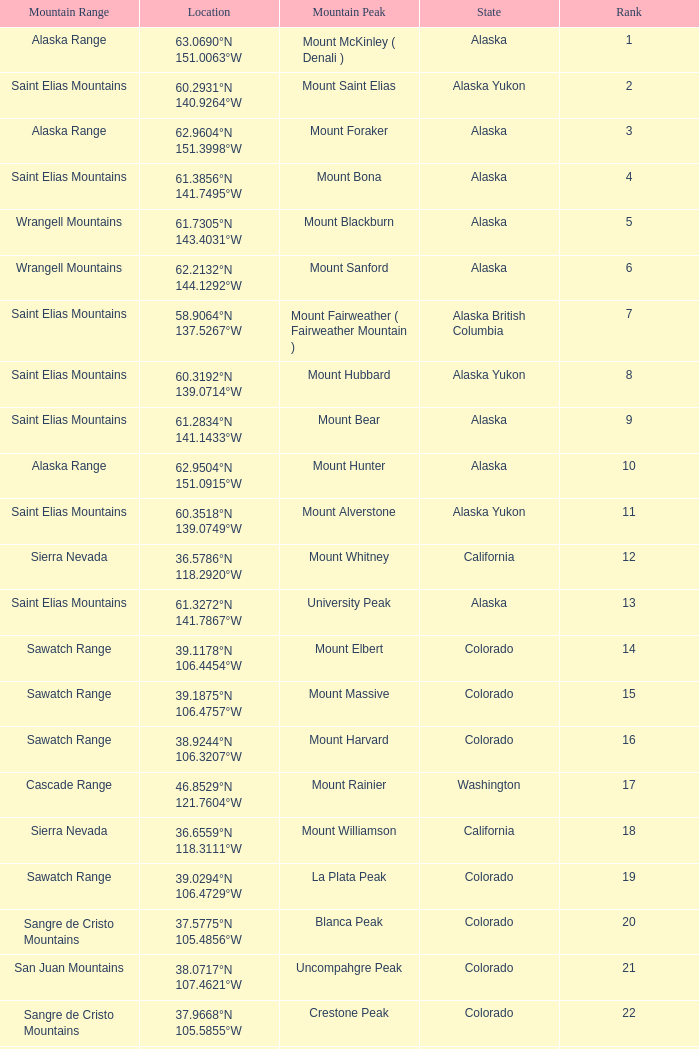What is the rank when the state is colorado and the location is 37.7859°n 107.7039°w? 83.0. 